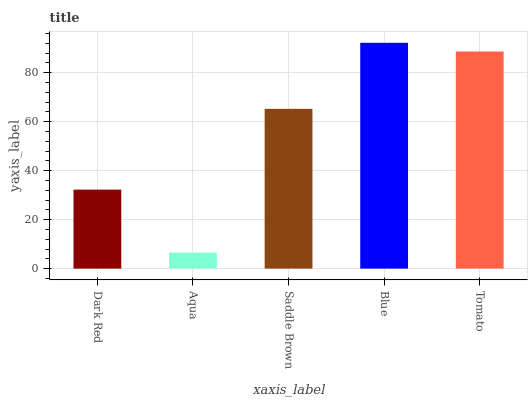Is Saddle Brown the minimum?
Answer yes or no. No. Is Saddle Brown the maximum?
Answer yes or no. No. Is Saddle Brown greater than Aqua?
Answer yes or no. Yes. Is Aqua less than Saddle Brown?
Answer yes or no. Yes. Is Aqua greater than Saddle Brown?
Answer yes or no. No. Is Saddle Brown less than Aqua?
Answer yes or no. No. Is Saddle Brown the high median?
Answer yes or no. Yes. Is Saddle Brown the low median?
Answer yes or no. Yes. Is Dark Red the high median?
Answer yes or no. No. Is Aqua the low median?
Answer yes or no. No. 